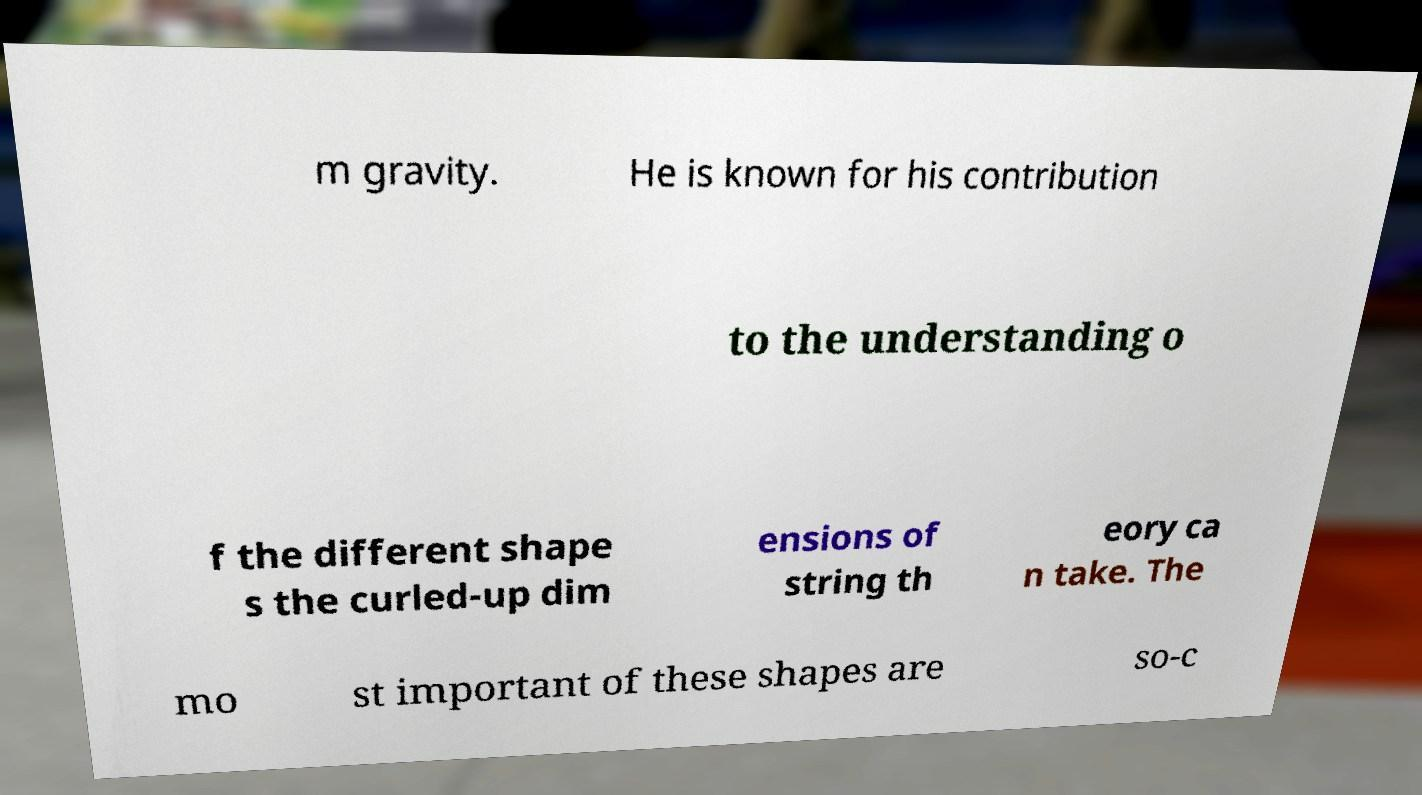Can you accurately transcribe the text from the provided image for me? m gravity. He is known for his contribution to the understanding o f the different shape s the curled-up dim ensions of string th eory ca n take. The mo st important of these shapes are so-c 